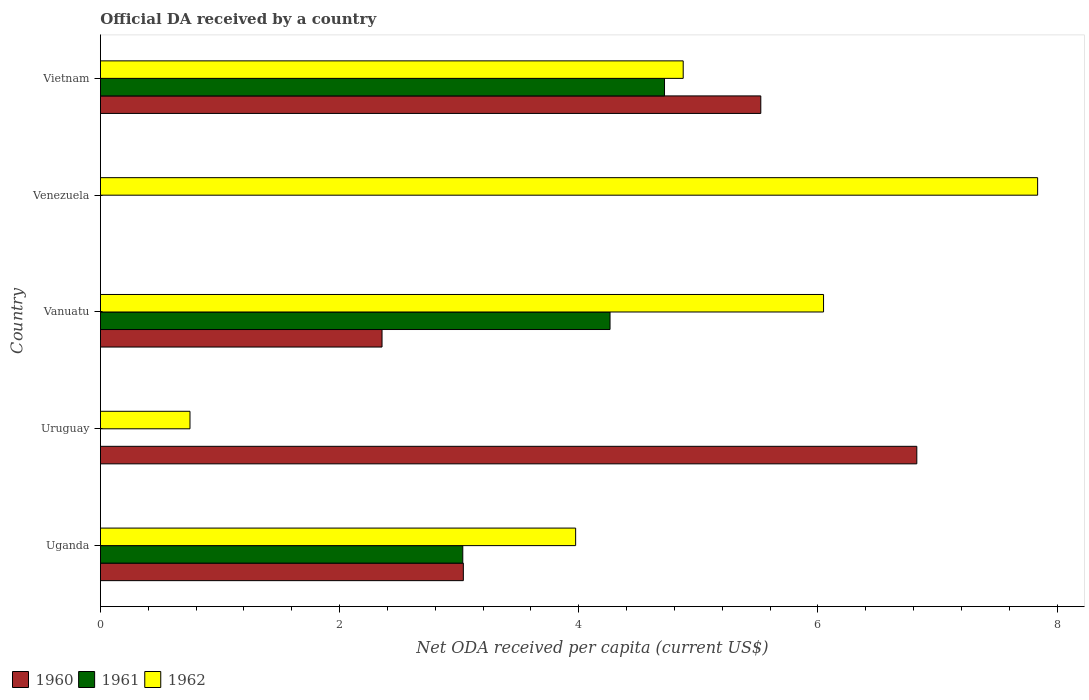Are the number of bars on each tick of the Y-axis equal?
Keep it short and to the point. No. How many bars are there on the 3rd tick from the bottom?
Provide a short and direct response. 3. What is the label of the 3rd group of bars from the top?
Offer a very short reply. Vanuatu. Across all countries, what is the maximum ODA received in in 1961?
Keep it short and to the point. 4.72. Across all countries, what is the minimum ODA received in in 1962?
Offer a terse response. 0.75. In which country was the ODA received in in 1962 maximum?
Provide a short and direct response. Venezuela. What is the total ODA received in in 1960 in the graph?
Keep it short and to the point. 17.74. What is the difference between the ODA received in in 1962 in Uganda and that in Venezuela?
Your answer should be compact. -3.86. What is the difference between the ODA received in in 1961 in Uruguay and the ODA received in in 1960 in Vanuatu?
Offer a very short reply. -2.35. What is the average ODA received in in 1960 per country?
Offer a very short reply. 3.55. What is the difference between the ODA received in in 1960 and ODA received in in 1961 in Uganda?
Offer a terse response. 0. What is the ratio of the ODA received in in 1962 in Vanuatu to that in Venezuela?
Keep it short and to the point. 0.77. What is the difference between the highest and the second highest ODA received in in 1961?
Offer a very short reply. 0.46. What is the difference between the highest and the lowest ODA received in in 1961?
Ensure brevity in your answer.  4.72. In how many countries, is the ODA received in in 1961 greater than the average ODA received in in 1961 taken over all countries?
Provide a short and direct response. 3. Does the graph contain any zero values?
Your response must be concise. Yes. How many legend labels are there?
Keep it short and to the point. 3. How are the legend labels stacked?
Keep it short and to the point. Horizontal. What is the title of the graph?
Provide a succinct answer. Official DA received by a country. Does "2010" appear as one of the legend labels in the graph?
Ensure brevity in your answer.  No. What is the label or title of the X-axis?
Make the answer very short. Net ODA received per capita (current US$). What is the Net ODA received per capita (current US$) of 1960 in Uganda?
Give a very brief answer. 3.03. What is the Net ODA received per capita (current US$) of 1961 in Uganda?
Ensure brevity in your answer.  3.03. What is the Net ODA received per capita (current US$) in 1962 in Uganda?
Keep it short and to the point. 3.97. What is the Net ODA received per capita (current US$) in 1960 in Uruguay?
Provide a succinct answer. 6.83. What is the Net ODA received per capita (current US$) of 1961 in Uruguay?
Give a very brief answer. 0. What is the Net ODA received per capita (current US$) of 1962 in Uruguay?
Give a very brief answer. 0.75. What is the Net ODA received per capita (current US$) of 1960 in Vanuatu?
Provide a succinct answer. 2.35. What is the Net ODA received per capita (current US$) in 1961 in Vanuatu?
Your response must be concise. 4.26. What is the Net ODA received per capita (current US$) of 1962 in Vanuatu?
Make the answer very short. 6.05. What is the Net ODA received per capita (current US$) in 1960 in Venezuela?
Your response must be concise. 0. What is the Net ODA received per capita (current US$) of 1962 in Venezuela?
Ensure brevity in your answer.  7.84. What is the Net ODA received per capita (current US$) in 1960 in Vietnam?
Provide a short and direct response. 5.52. What is the Net ODA received per capita (current US$) of 1961 in Vietnam?
Provide a succinct answer. 4.72. What is the Net ODA received per capita (current US$) of 1962 in Vietnam?
Offer a terse response. 4.87. Across all countries, what is the maximum Net ODA received per capita (current US$) in 1960?
Your answer should be compact. 6.83. Across all countries, what is the maximum Net ODA received per capita (current US$) of 1961?
Ensure brevity in your answer.  4.72. Across all countries, what is the maximum Net ODA received per capita (current US$) in 1962?
Give a very brief answer. 7.84. Across all countries, what is the minimum Net ODA received per capita (current US$) of 1960?
Keep it short and to the point. 0. Across all countries, what is the minimum Net ODA received per capita (current US$) in 1962?
Give a very brief answer. 0.75. What is the total Net ODA received per capita (current US$) in 1960 in the graph?
Make the answer very short. 17.74. What is the total Net ODA received per capita (current US$) of 1961 in the graph?
Your answer should be very brief. 12.01. What is the total Net ODA received per capita (current US$) in 1962 in the graph?
Provide a short and direct response. 23.48. What is the difference between the Net ODA received per capita (current US$) of 1960 in Uganda and that in Uruguay?
Ensure brevity in your answer.  -3.79. What is the difference between the Net ODA received per capita (current US$) in 1962 in Uganda and that in Uruguay?
Provide a succinct answer. 3.22. What is the difference between the Net ODA received per capita (current US$) of 1960 in Uganda and that in Vanuatu?
Give a very brief answer. 0.68. What is the difference between the Net ODA received per capita (current US$) in 1961 in Uganda and that in Vanuatu?
Give a very brief answer. -1.23. What is the difference between the Net ODA received per capita (current US$) in 1962 in Uganda and that in Vanuatu?
Your answer should be compact. -2.07. What is the difference between the Net ODA received per capita (current US$) in 1962 in Uganda and that in Venezuela?
Provide a short and direct response. -3.86. What is the difference between the Net ODA received per capita (current US$) of 1960 in Uganda and that in Vietnam?
Your answer should be very brief. -2.49. What is the difference between the Net ODA received per capita (current US$) of 1961 in Uganda and that in Vietnam?
Your response must be concise. -1.69. What is the difference between the Net ODA received per capita (current US$) in 1962 in Uganda and that in Vietnam?
Your answer should be compact. -0.9. What is the difference between the Net ODA received per capita (current US$) of 1960 in Uruguay and that in Vanuatu?
Keep it short and to the point. 4.47. What is the difference between the Net ODA received per capita (current US$) in 1962 in Uruguay and that in Vanuatu?
Ensure brevity in your answer.  -5.3. What is the difference between the Net ODA received per capita (current US$) of 1962 in Uruguay and that in Venezuela?
Keep it short and to the point. -7.09. What is the difference between the Net ODA received per capita (current US$) in 1960 in Uruguay and that in Vietnam?
Offer a very short reply. 1.3. What is the difference between the Net ODA received per capita (current US$) of 1962 in Uruguay and that in Vietnam?
Offer a very short reply. -4.12. What is the difference between the Net ODA received per capita (current US$) of 1962 in Vanuatu and that in Venezuela?
Make the answer very short. -1.79. What is the difference between the Net ODA received per capita (current US$) of 1960 in Vanuatu and that in Vietnam?
Provide a short and direct response. -3.17. What is the difference between the Net ODA received per capita (current US$) in 1961 in Vanuatu and that in Vietnam?
Make the answer very short. -0.46. What is the difference between the Net ODA received per capita (current US$) in 1962 in Vanuatu and that in Vietnam?
Offer a terse response. 1.17. What is the difference between the Net ODA received per capita (current US$) of 1962 in Venezuela and that in Vietnam?
Provide a succinct answer. 2.96. What is the difference between the Net ODA received per capita (current US$) in 1960 in Uganda and the Net ODA received per capita (current US$) in 1962 in Uruguay?
Offer a very short reply. 2.29. What is the difference between the Net ODA received per capita (current US$) in 1961 in Uganda and the Net ODA received per capita (current US$) in 1962 in Uruguay?
Your response must be concise. 2.28. What is the difference between the Net ODA received per capita (current US$) of 1960 in Uganda and the Net ODA received per capita (current US$) of 1961 in Vanuatu?
Provide a succinct answer. -1.23. What is the difference between the Net ODA received per capita (current US$) of 1960 in Uganda and the Net ODA received per capita (current US$) of 1962 in Vanuatu?
Give a very brief answer. -3.01. What is the difference between the Net ODA received per capita (current US$) in 1961 in Uganda and the Net ODA received per capita (current US$) in 1962 in Vanuatu?
Offer a very short reply. -3.02. What is the difference between the Net ODA received per capita (current US$) of 1960 in Uganda and the Net ODA received per capita (current US$) of 1962 in Venezuela?
Provide a succinct answer. -4.8. What is the difference between the Net ODA received per capita (current US$) of 1961 in Uganda and the Net ODA received per capita (current US$) of 1962 in Venezuela?
Keep it short and to the point. -4.81. What is the difference between the Net ODA received per capita (current US$) of 1960 in Uganda and the Net ODA received per capita (current US$) of 1961 in Vietnam?
Offer a terse response. -1.68. What is the difference between the Net ODA received per capita (current US$) of 1960 in Uganda and the Net ODA received per capita (current US$) of 1962 in Vietnam?
Make the answer very short. -1.84. What is the difference between the Net ODA received per capita (current US$) of 1961 in Uganda and the Net ODA received per capita (current US$) of 1962 in Vietnam?
Provide a succinct answer. -1.84. What is the difference between the Net ODA received per capita (current US$) of 1960 in Uruguay and the Net ODA received per capita (current US$) of 1961 in Vanuatu?
Make the answer very short. 2.57. What is the difference between the Net ODA received per capita (current US$) of 1960 in Uruguay and the Net ODA received per capita (current US$) of 1962 in Vanuatu?
Provide a succinct answer. 0.78. What is the difference between the Net ODA received per capita (current US$) in 1960 in Uruguay and the Net ODA received per capita (current US$) in 1962 in Venezuela?
Offer a terse response. -1.01. What is the difference between the Net ODA received per capita (current US$) of 1960 in Uruguay and the Net ODA received per capita (current US$) of 1961 in Vietnam?
Provide a succinct answer. 2.11. What is the difference between the Net ODA received per capita (current US$) of 1960 in Uruguay and the Net ODA received per capita (current US$) of 1962 in Vietnam?
Provide a succinct answer. 1.95. What is the difference between the Net ODA received per capita (current US$) of 1960 in Vanuatu and the Net ODA received per capita (current US$) of 1962 in Venezuela?
Offer a terse response. -5.48. What is the difference between the Net ODA received per capita (current US$) in 1961 in Vanuatu and the Net ODA received per capita (current US$) in 1962 in Venezuela?
Keep it short and to the point. -3.58. What is the difference between the Net ODA received per capita (current US$) of 1960 in Vanuatu and the Net ODA received per capita (current US$) of 1961 in Vietnam?
Provide a short and direct response. -2.36. What is the difference between the Net ODA received per capita (current US$) of 1960 in Vanuatu and the Net ODA received per capita (current US$) of 1962 in Vietnam?
Your answer should be compact. -2.52. What is the difference between the Net ODA received per capita (current US$) of 1961 in Vanuatu and the Net ODA received per capita (current US$) of 1962 in Vietnam?
Your response must be concise. -0.61. What is the average Net ODA received per capita (current US$) of 1960 per country?
Your answer should be compact. 3.55. What is the average Net ODA received per capita (current US$) in 1961 per country?
Offer a very short reply. 2.4. What is the average Net ODA received per capita (current US$) of 1962 per country?
Provide a short and direct response. 4.7. What is the difference between the Net ODA received per capita (current US$) of 1960 and Net ODA received per capita (current US$) of 1961 in Uganda?
Make the answer very short. 0. What is the difference between the Net ODA received per capita (current US$) in 1960 and Net ODA received per capita (current US$) in 1962 in Uganda?
Offer a terse response. -0.94. What is the difference between the Net ODA received per capita (current US$) in 1961 and Net ODA received per capita (current US$) in 1962 in Uganda?
Provide a short and direct response. -0.94. What is the difference between the Net ODA received per capita (current US$) of 1960 and Net ODA received per capita (current US$) of 1962 in Uruguay?
Offer a very short reply. 6.08. What is the difference between the Net ODA received per capita (current US$) of 1960 and Net ODA received per capita (current US$) of 1961 in Vanuatu?
Offer a very short reply. -1.91. What is the difference between the Net ODA received per capita (current US$) in 1960 and Net ODA received per capita (current US$) in 1962 in Vanuatu?
Offer a very short reply. -3.69. What is the difference between the Net ODA received per capita (current US$) in 1961 and Net ODA received per capita (current US$) in 1962 in Vanuatu?
Offer a very short reply. -1.79. What is the difference between the Net ODA received per capita (current US$) of 1960 and Net ODA received per capita (current US$) of 1961 in Vietnam?
Provide a short and direct response. 0.81. What is the difference between the Net ODA received per capita (current US$) of 1960 and Net ODA received per capita (current US$) of 1962 in Vietnam?
Keep it short and to the point. 0.65. What is the difference between the Net ODA received per capita (current US$) in 1961 and Net ODA received per capita (current US$) in 1962 in Vietnam?
Provide a succinct answer. -0.16. What is the ratio of the Net ODA received per capita (current US$) of 1960 in Uganda to that in Uruguay?
Your response must be concise. 0.44. What is the ratio of the Net ODA received per capita (current US$) in 1962 in Uganda to that in Uruguay?
Offer a terse response. 5.31. What is the ratio of the Net ODA received per capita (current US$) in 1960 in Uganda to that in Vanuatu?
Keep it short and to the point. 1.29. What is the ratio of the Net ODA received per capita (current US$) in 1961 in Uganda to that in Vanuatu?
Offer a terse response. 0.71. What is the ratio of the Net ODA received per capita (current US$) in 1962 in Uganda to that in Vanuatu?
Provide a succinct answer. 0.66. What is the ratio of the Net ODA received per capita (current US$) of 1962 in Uganda to that in Venezuela?
Give a very brief answer. 0.51. What is the ratio of the Net ODA received per capita (current US$) of 1960 in Uganda to that in Vietnam?
Ensure brevity in your answer.  0.55. What is the ratio of the Net ODA received per capita (current US$) of 1961 in Uganda to that in Vietnam?
Offer a very short reply. 0.64. What is the ratio of the Net ODA received per capita (current US$) of 1962 in Uganda to that in Vietnam?
Ensure brevity in your answer.  0.82. What is the ratio of the Net ODA received per capita (current US$) in 1960 in Uruguay to that in Vanuatu?
Your answer should be very brief. 2.9. What is the ratio of the Net ODA received per capita (current US$) of 1962 in Uruguay to that in Vanuatu?
Offer a terse response. 0.12. What is the ratio of the Net ODA received per capita (current US$) in 1962 in Uruguay to that in Venezuela?
Ensure brevity in your answer.  0.1. What is the ratio of the Net ODA received per capita (current US$) in 1960 in Uruguay to that in Vietnam?
Your answer should be very brief. 1.24. What is the ratio of the Net ODA received per capita (current US$) of 1962 in Uruguay to that in Vietnam?
Your answer should be compact. 0.15. What is the ratio of the Net ODA received per capita (current US$) in 1962 in Vanuatu to that in Venezuela?
Make the answer very short. 0.77. What is the ratio of the Net ODA received per capita (current US$) of 1960 in Vanuatu to that in Vietnam?
Ensure brevity in your answer.  0.43. What is the ratio of the Net ODA received per capita (current US$) in 1961 in Vanuatu to that in Vietnam?
Provide a succinct answer. 0.9. What is the ratio of the Net ODA received per capita (current US$) of 1962 in Vanuatu to that in Vietnam?
Offer a terse response. 1.24. What is the ratio of the Net ODA received per capita (current US$) of 1962 in Venezuela to that in Vietnam?
Your answer should be compact. 1.61. What is the difference between the highest and the second highest Net ODA received per capita (current US$) in 1960?
Keep it short and to the point. 1.3. What is the difference between the highest and the second highest Net ODA received per capita (current US$) of 1961?
Offer a very short reply. 0.46. What is the difference between the highest and the second highest Net ODA received per capita (current US$) of 1962?
Offer a terse response. 1.79. What is the difference between the highest and the lowest Net ODA received per capita (current US$) of 1960?
Provide a succinct answer. 6.83. What is the difference between the highest and the lowest Net ODA received per capita (current US$) in 1961?
Offer a very short reply. 4.72. What is the difference between the highest and the lowest Net ODA received per capita (current US$) in 1962?
Provide a succinct answer. 7.09. 